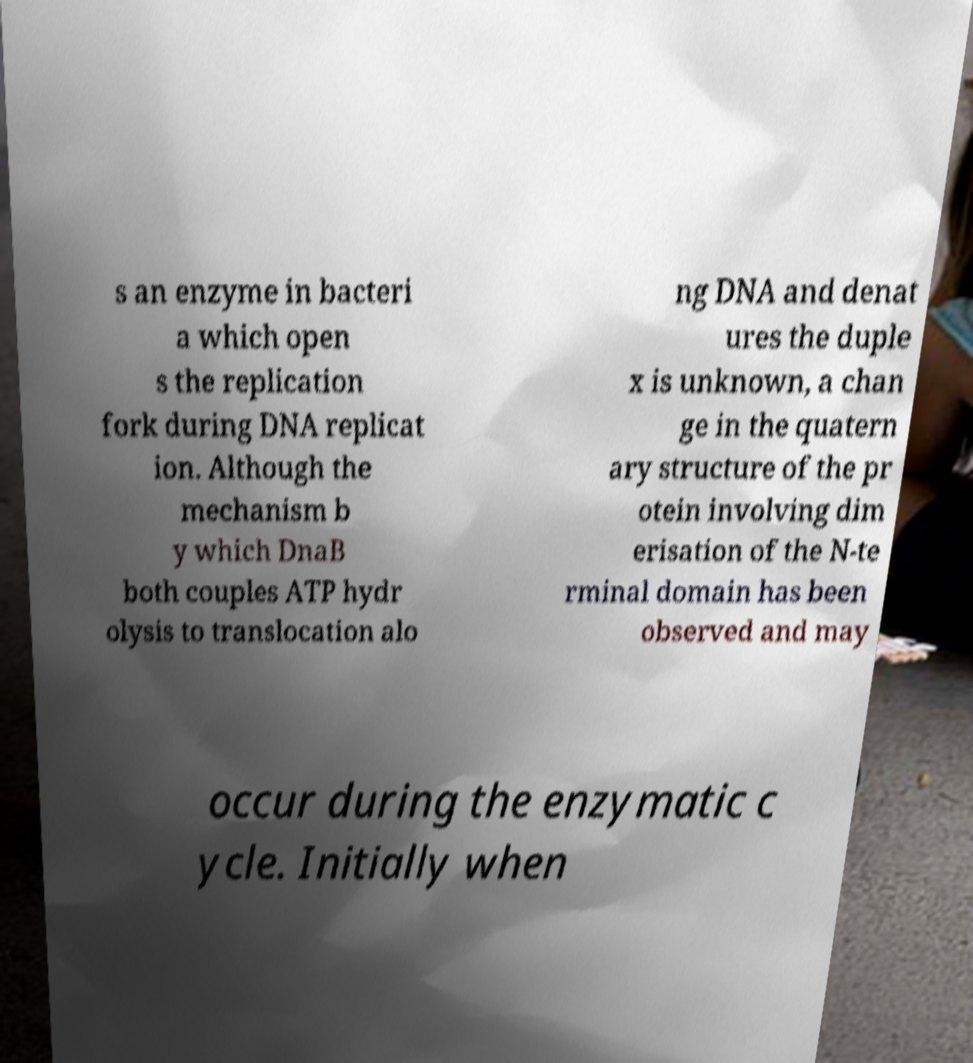For documentation purposes, I need the text within this image transcribed. Could you provide that? s an enzyme in bacteri a which open s the replication fork during DNA replicat ion. Although the mechanism b y which DnaB both couples ATP hydr olysis to translocation alo ng DNA and denat ures the duple x is unknown, a chan ge in the quatern ary structure of the pr otein involving dim erisation of the N-te rminal domain has been observed and may occur during the enzymatic c ycle. Initially when 